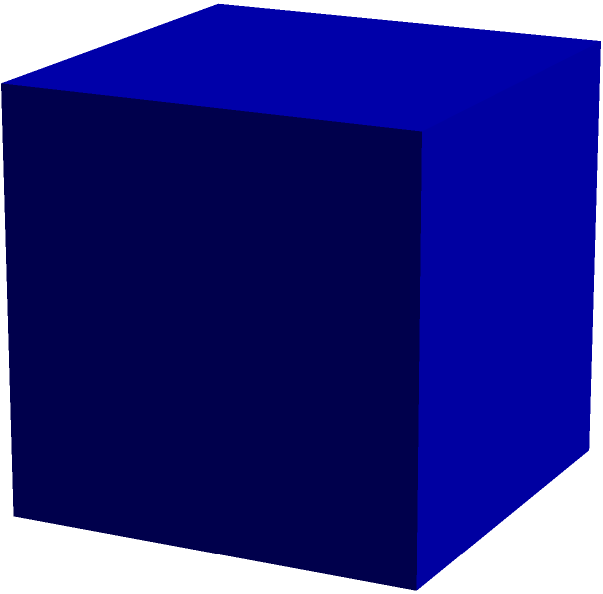As a tax advisor dealing with international taxation, you need to store important documents securely. You have a cube-shaped document storage box with each side measuring 30 cm. What is the total surface area of this box in square meters? To calculate the surface area of a cube, we need to follow these steps:

1. Identify the formula for the surface area of a cube:
   Surface Area = $6s^2$, where $s$ is the length of one side

2. Convert the given side length from centimeters to meters:
   $30 \text{ cm} = 0.30 \text{ m}$

3. Apply the formula using the side length in meters:
   Surface Area = $6 \times (0.30 \text{ m})^2$

4. Calculate the result:
   Surface Area = $6 \times 0.09 \text{ m}^2 = 0.54 \text{ m}^2$

Therefore, the total surface area of the cube-shaped document storage box is 0.54 square meters.
Answer: $0.54 \text{ m}^2$ 